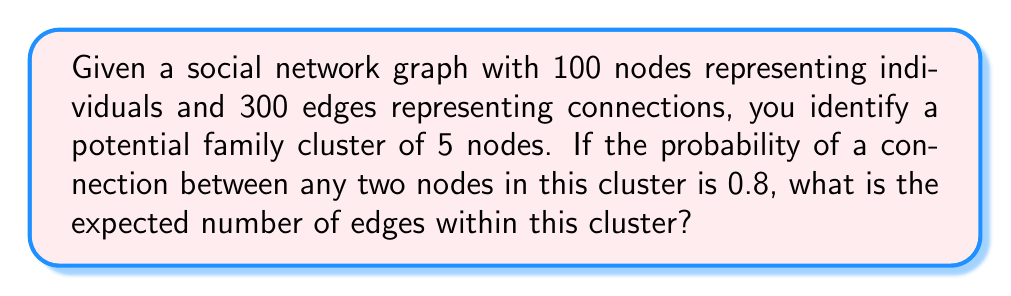Provide a solution to this math problem. To solve this problem, we'll follow these steps:

1) First, we need to calculate the total number of possible connections within the cluster of 5 nodes. This is given by the combination formula:

   $$\binom{5}{2} = \frac{5!}{2!(5-2)!} = \frac{5 \cdot 4}{2 \cdot 1} = 10$$

2) Now, we know that each of these potential connections has a probability of 0.8 of actually existing.

3) In probability theory, the expected value of a binomial distribution (which this scenario follows) is given by the formula:

   $$E(X) = np$$

   Where:
   $n$ is the number of trials (in this case, the number of potential connections)
   $p$ is the probability of success on each trial (in this case, the probability of a connection existing)

4) Plugging in our values:

   $$E(X) = 10 \cdot 0.8 = 8$$

Therefore, the expected number of edges within this cluster is 8.
Answer: 8 